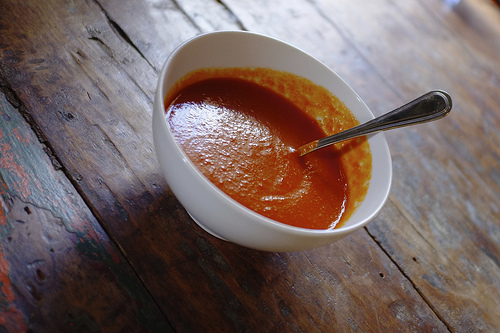<image>
Can you confirm if the spoon is behind the bowl? No. The spoon is not behind the bowl. From this viewpoint, the spoon appears to be positioned elsewhere in the scene. 